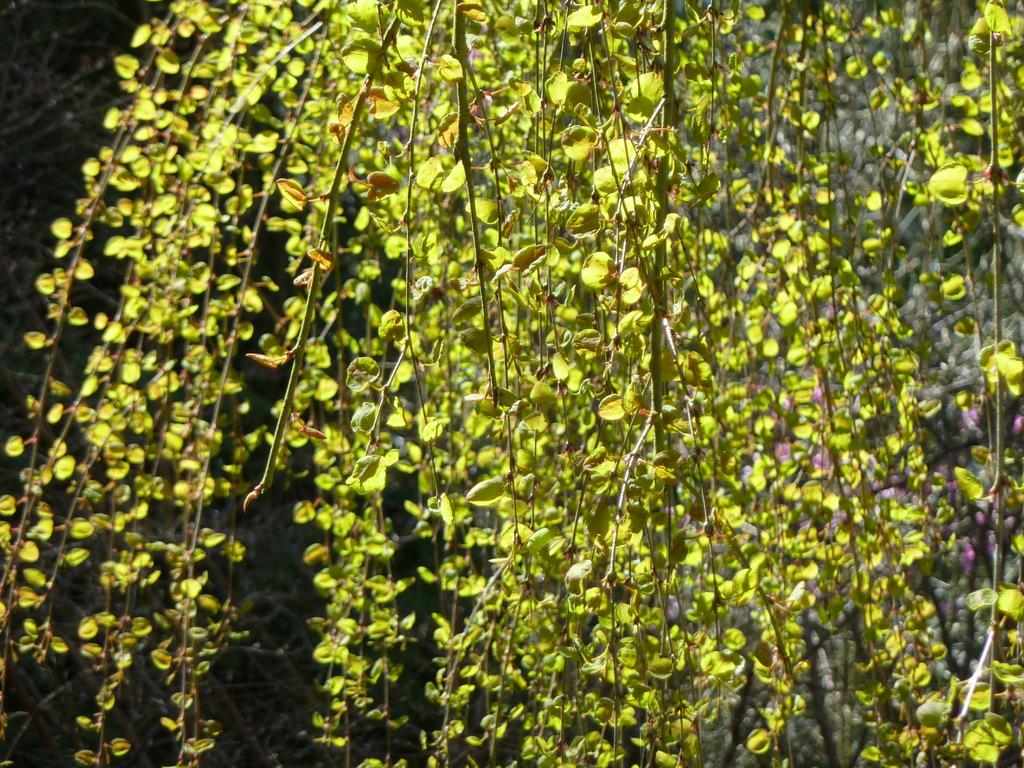What type of plant is in the image? There is a creeper plant in the image. What color are the leaves and stems of the plant? The leaves and stems of the plant are green. What can be seen in the background of the image? There is a rock in the background of the image. How many snails are crawling on the creeper plant in the image? There are no snails visible on the creeper plant in the image. What type of horse can be seen grazing near the rock in the background? There is no horse present in the image; it only features a creeper plant and a rock in the background. 